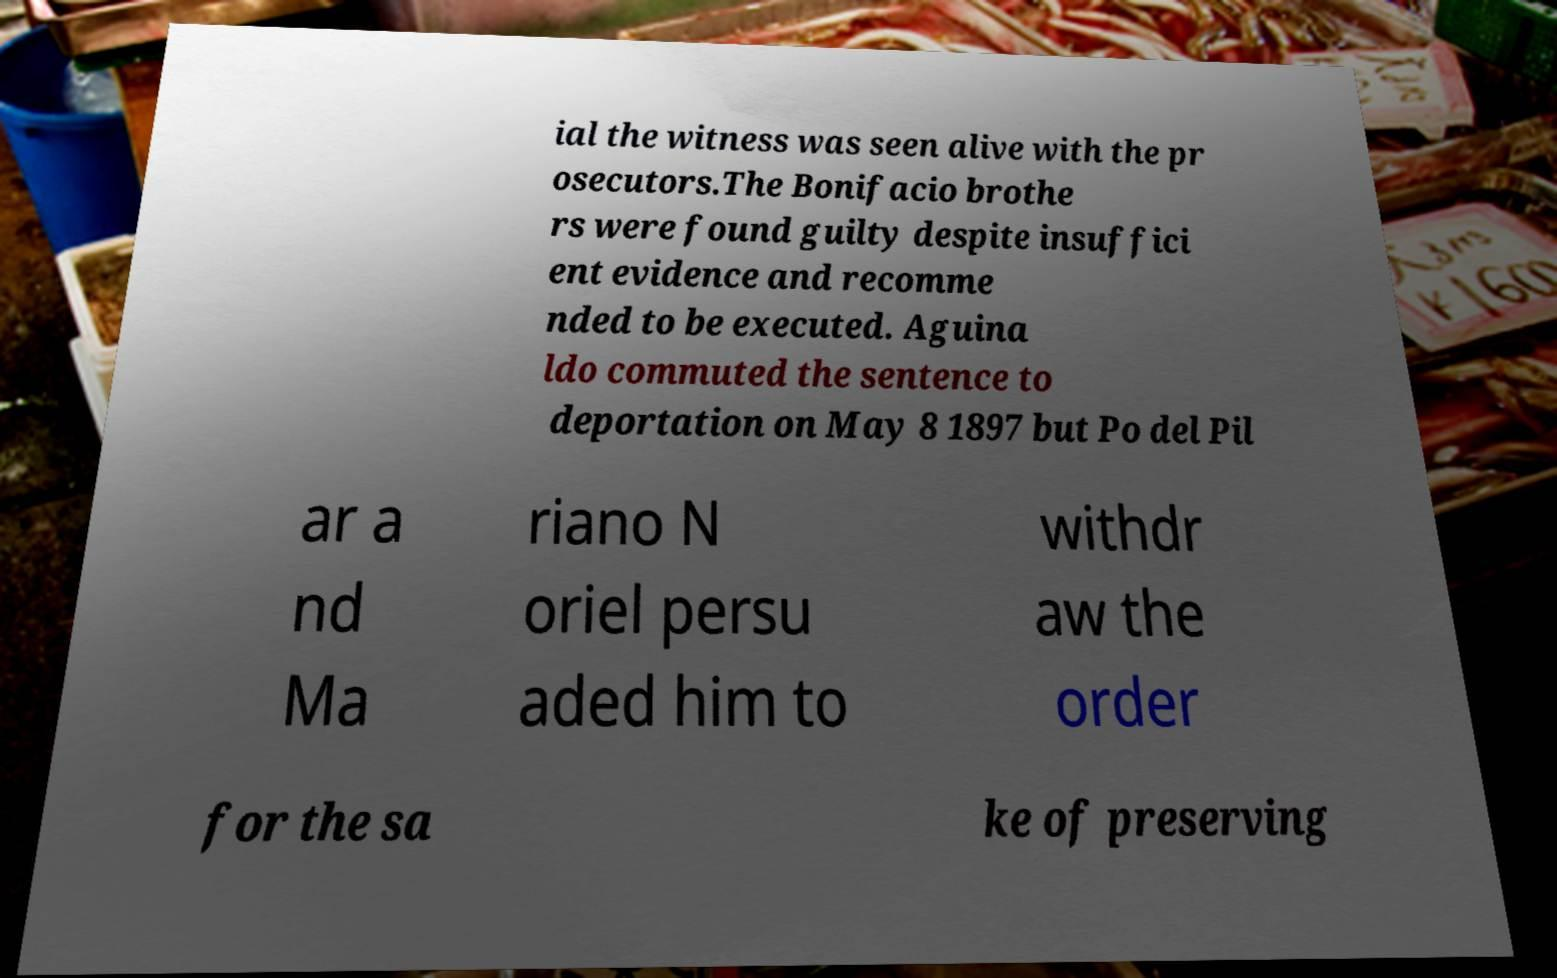I need the written content from this picture converted into text. Can you do that? ial the witness was seen alive with the pr osecutors.The Bonifacio brothe rs were found guilty despite insuffici ent evidence and recomme nded to be executed. Aguina ldo commuted the sentence to deportation on May 8 1897 but Po del Pil ar a nd Ma riano N oriel persu aded him to withdr aw the order for the sa ke of preserving 